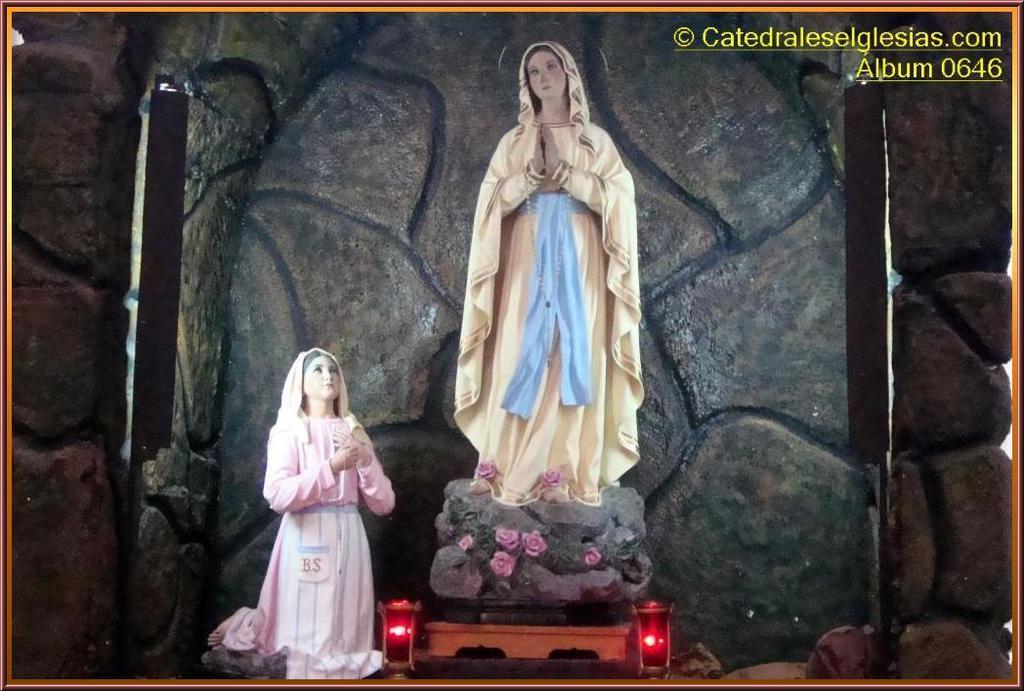Can you describe this image briefly? In this picture I can see the idols. I can see the stone wall in the background. 